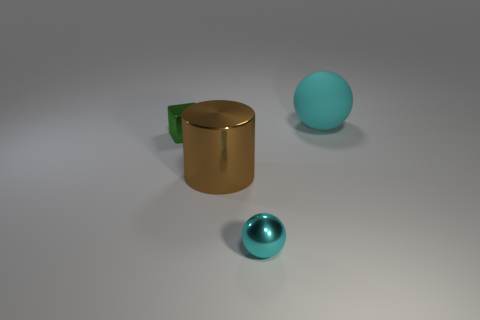Add 4 brown blocks. How many objects exist? 8 Subtract all blocks. How many objects are left? 3 Subtract 0 brown blocks. How many objects are left? 4 Subtract all metallic balls. Subtract all cyan things. How many objects are left? 1 Add 2 large brown metallic cylinders. How many large brown metallic cylinders are left? 3 Add 2 small blocks. How many small blocks exist? 3 